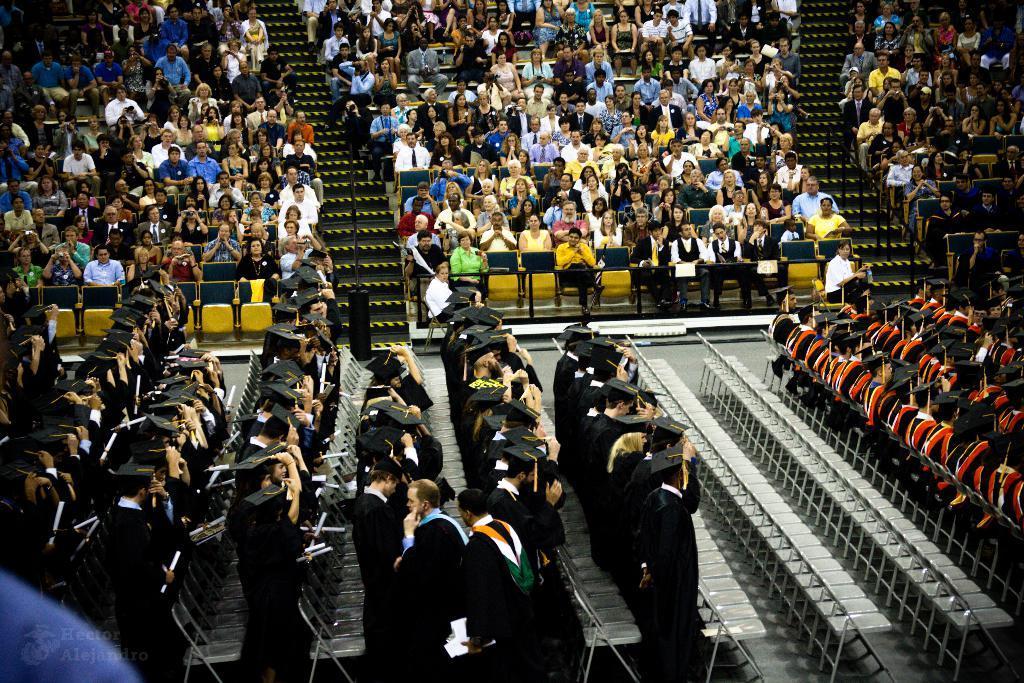Describe this image in one or two sentences. This image is taken during convocation time. In this image we can see many people sitting on the chairs. In the bottom left corner we can see a logo with the text. 